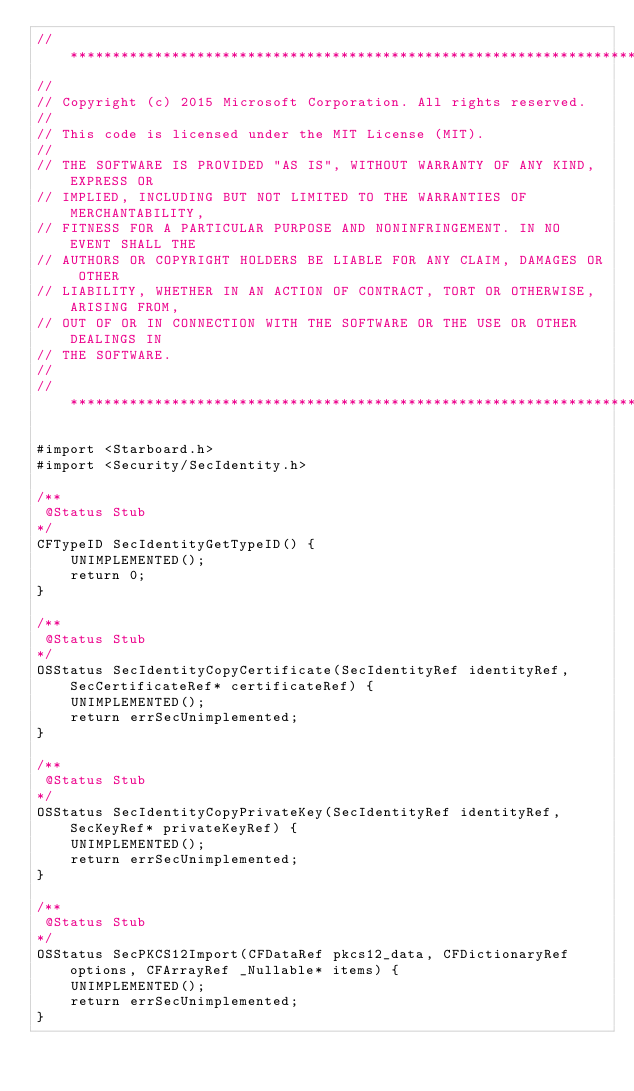Convert code to text. <code><loc_0><loc_0><loc_500><loc_500><_ObjectiveC_>//******************************************************************************
//
// Copyright (c) 2015 Microsoft Corporation. All rights reserved.
//
// This code is licensed under the MIT License (MIT).
//
// THE SOFTWARE IS PROVIDED "AS IS", WITHOUT WARRANTY OF ANY KIND, EXPRESS OR
// IMPLIED, INCLUDING BUT NOT LIMITED TO THE WARRANTIES OF MERCHANTABILITY,
// FITNESS FOR A PARTICULAR PURPOSE AND NONINFRINGEMENT. IN NO EVENT SHALL THE
// AUTHORS OR COPYRIGHT HOLDERS BE LIABLE FOR ANY CLAIM, DAMAGES OR OTHER
// LIABILITY, WHETHER IN AN ACTION OF CONTRACT, TORT OR OTHERWISE, ARISING FROM,
// OUT OF OR IN CONNECTION WITH THE SOFTWARE OR THE USE OR OTHER DEALINGS IN
// THE SOFTWARE.
//
//******************************************************************************

#import <Starboard.h>
#import <Security/SecIdentity.h>

/**
 @Status Stub
*/
CFTypeID SecIdentityGetTypeID() {
    UNIMPLEMENTED();
    return 0;
}

/**
 @Status Stub
*/
OSStatus SecIdentityCopyCertificate(SecIdentityRef identityRef, SecCertificateRef* certificateRef) {
    UNIMPLEMENTED();
    return errSecUnimplemented;
}

/**
 @Status Stub
*/
OSStatus SecIdentityCopyPrivateKey(SecIdentityRef identityRef, SecKeyRef* privateKeyRef) {
    UNIMPLEMENTED();
    return errSecUnimplemented;
}

/**
 @Status Stub
*/
OSStatus SecPKCS12Import(CFDataRef pkcs12_data, CFDictionaryRef options, CFArrayRef _Nullable* items) {
    UNIMPLEMENTED();
    return errSecUnimplemented;
}</code> 